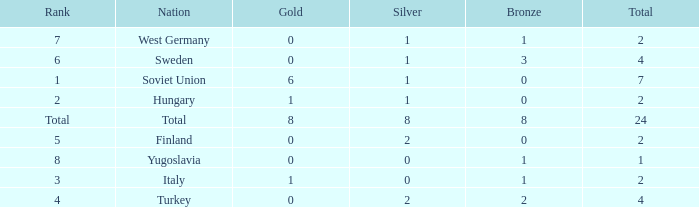What is the total sum when the rank is 8 and the number of bronze medals is less than 1? None. 